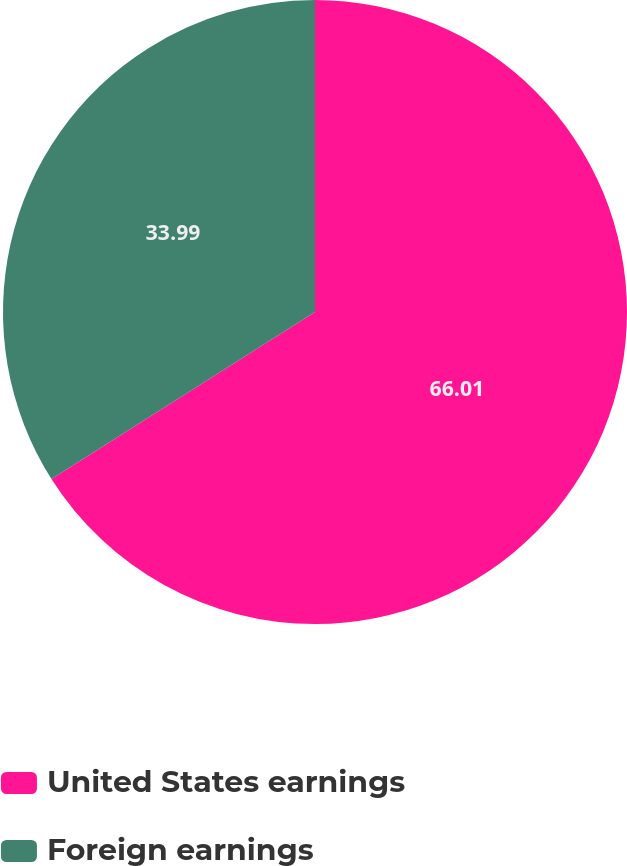Convert chart to OTSL. <chart><loc_0><loc_0><loc_500><loc_500><pie_chart><fcel>United States earnings<fcel>Foreign earnings<nl><fcel>66.01%<fcel>33.99%<nl></chart> 